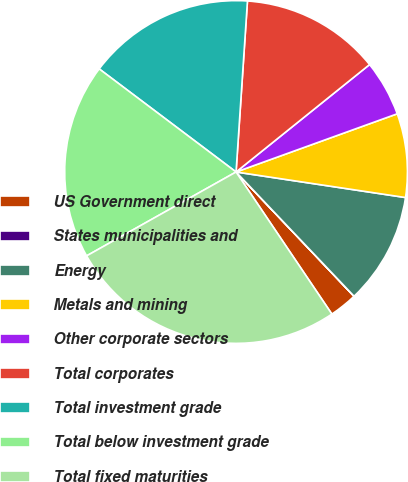Convert chart to OTSL. <chart><loc_0><loc_0><loc_500><loc_500><pie_chart><fcel>US Government direct<fcel>States municipalities and<fcel>Energy<fcel>Metals and mining<fcel>Other corporate sectors<fcel>Total corporates<fcel>Total investment grade<fcel>Total below investment grade<fcel>Total fixed maturities<nl><fcel>2.64%<fcel>0.01%<fcel>10.53%<fcel>7.9%<fcel>5.27%<fcel>13.16%<fcel>15.79%<fcel>18.42%<fcel>26.31%<nl></chart> 